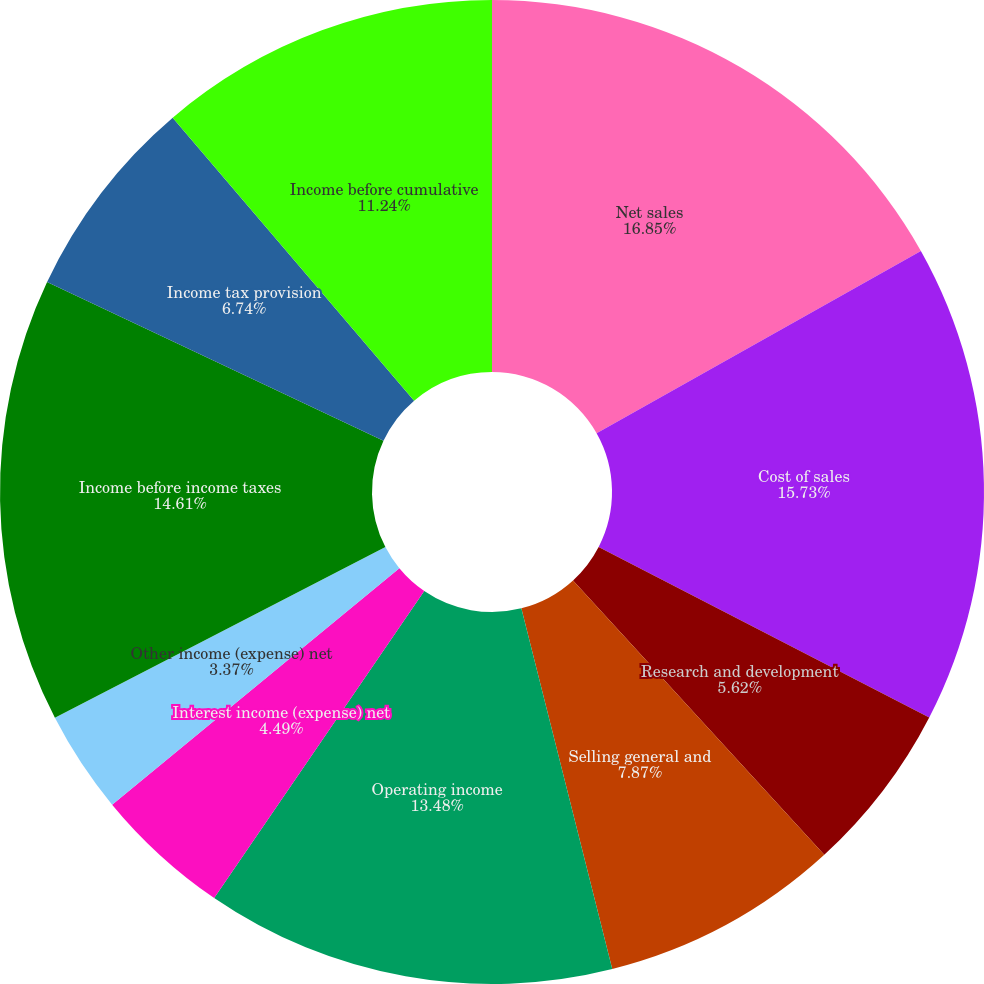Convert chart. <chart><loc_0><loc_0><loc_500><loc_500><pie_chart><fcel>Net sales<fcel>Cost of sales<fcel>Research and development<fcel>Selling general and<fcel>Operating income<fcel>Interest income (expense) net<fcel>Other income (expense) net<fcel>Income before income taxes<fcel>Income tax provision<fcel>Income before cumulative<nl><fcel>16.85%<fcel>15.73%<fcel>5.62%<fcel>7.87%<fcel>13.48%<fcel>4.49%<fcel>3.37%<fcel>14.61%<fcel>6.74%<fcel>11.24%<nl></chart> 